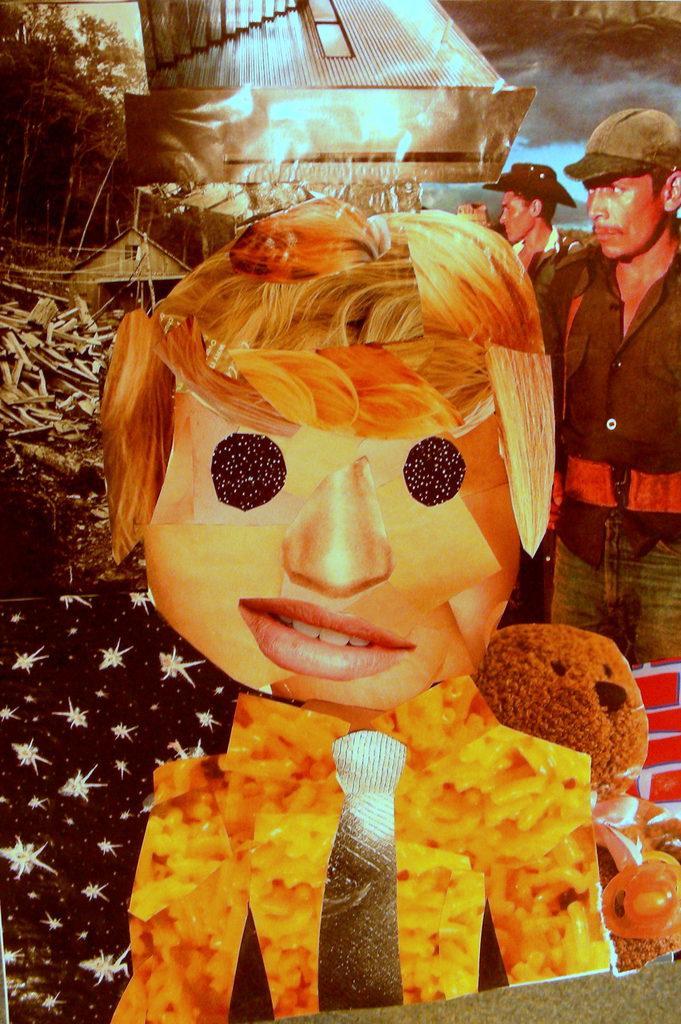Could you give a brief overview of what you see in this image? In this image we can see a poster of few people, a cartoon picture of a person, a toy, trees and few other objects. 